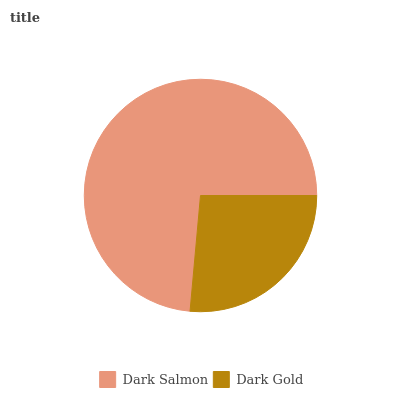Is Dark Gold the minimum?
Answer yes or no. Yes. Is Dark Salmon the maximum?
Answer yes or no. Yes. Is Dark Gold the maximum?
Answer yes or no. No. Is Dark Salmon greater than Dark Gold?
Answer yes or no. Yes. Is Dark Gold less than Dark Salmon?
Answer yes or no. Yes. Is Dark Gold greater than Dark Salmon?
Answer yes or no. No. Is Dark Salmon less than Dark Gold?
Answer yes or no. No. Is Dark Salmon the high median?
Answer yes or no. Yes. Is Dark Gold the low median?
Answer yes or no. Yes. Is Dark Gold the high median?
Answer yes or no. No. Is Dark Salmon the low median?
Answer yes or no. No. 